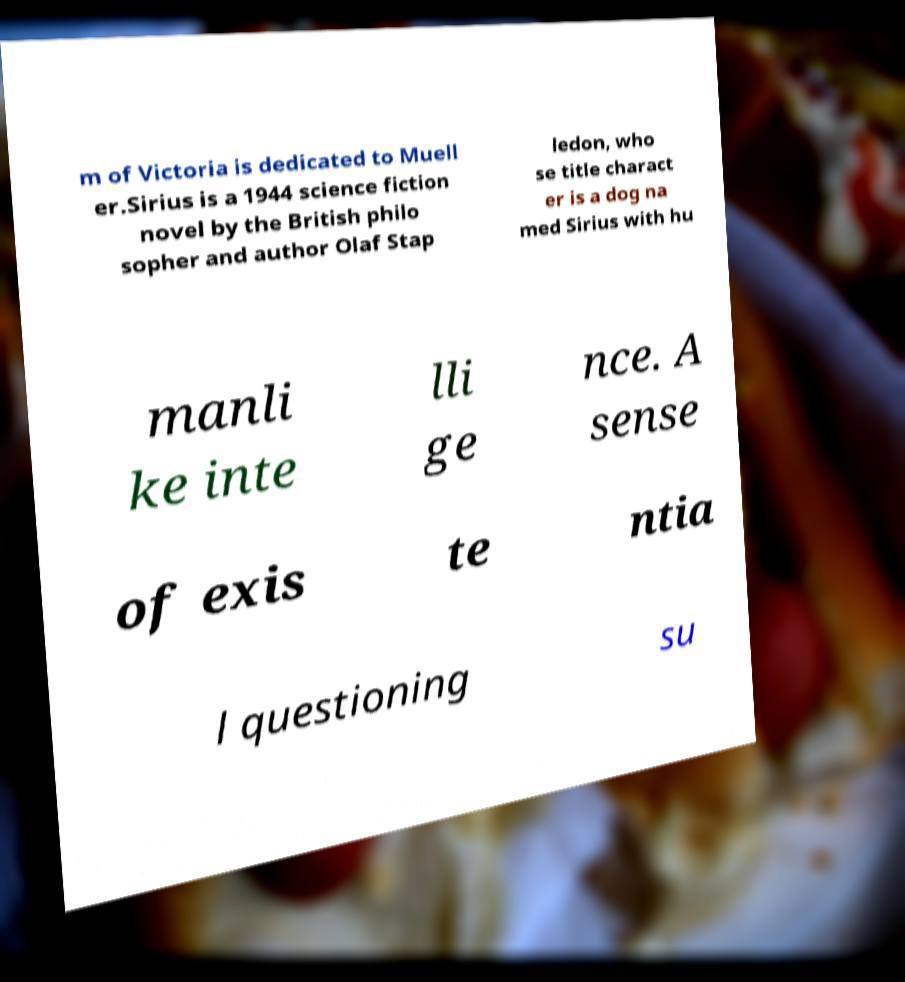For documentation purposes, I need the text within this image transcribed. Could you provide that? m of Victoria is dedicated to Muell er.Sirius is a 1944 science fiction novel by the British philo sopher and author Olaf Stap ledon, who se title charact er is a dog na med Sirius with hu manli ke inte lli ge nce. A sense of exis te ntia l questioning su 